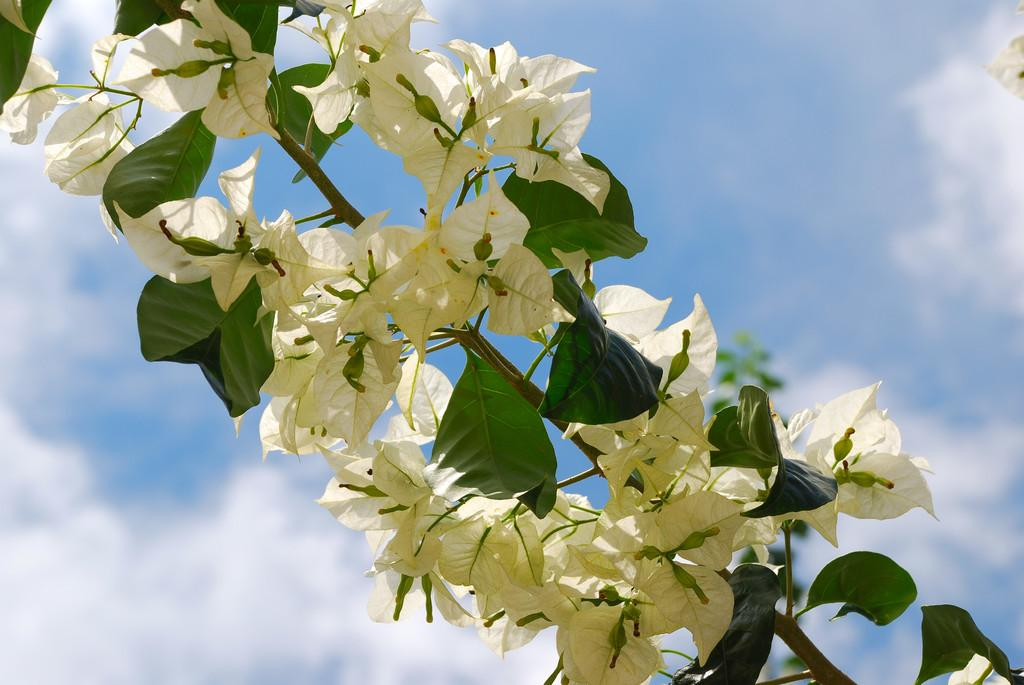What type of plant is visible in the image? There are flowers on a plant in the image. What can be seen in the background of the image? The sky is visible in the background of the image. What is the condition of the sky in the image? Clouds are present in the sky. What type of carriage is being driven by the judge in the image? There is no carriage or judge present in the image; it features a plant with flowers and a sky with clouds. 